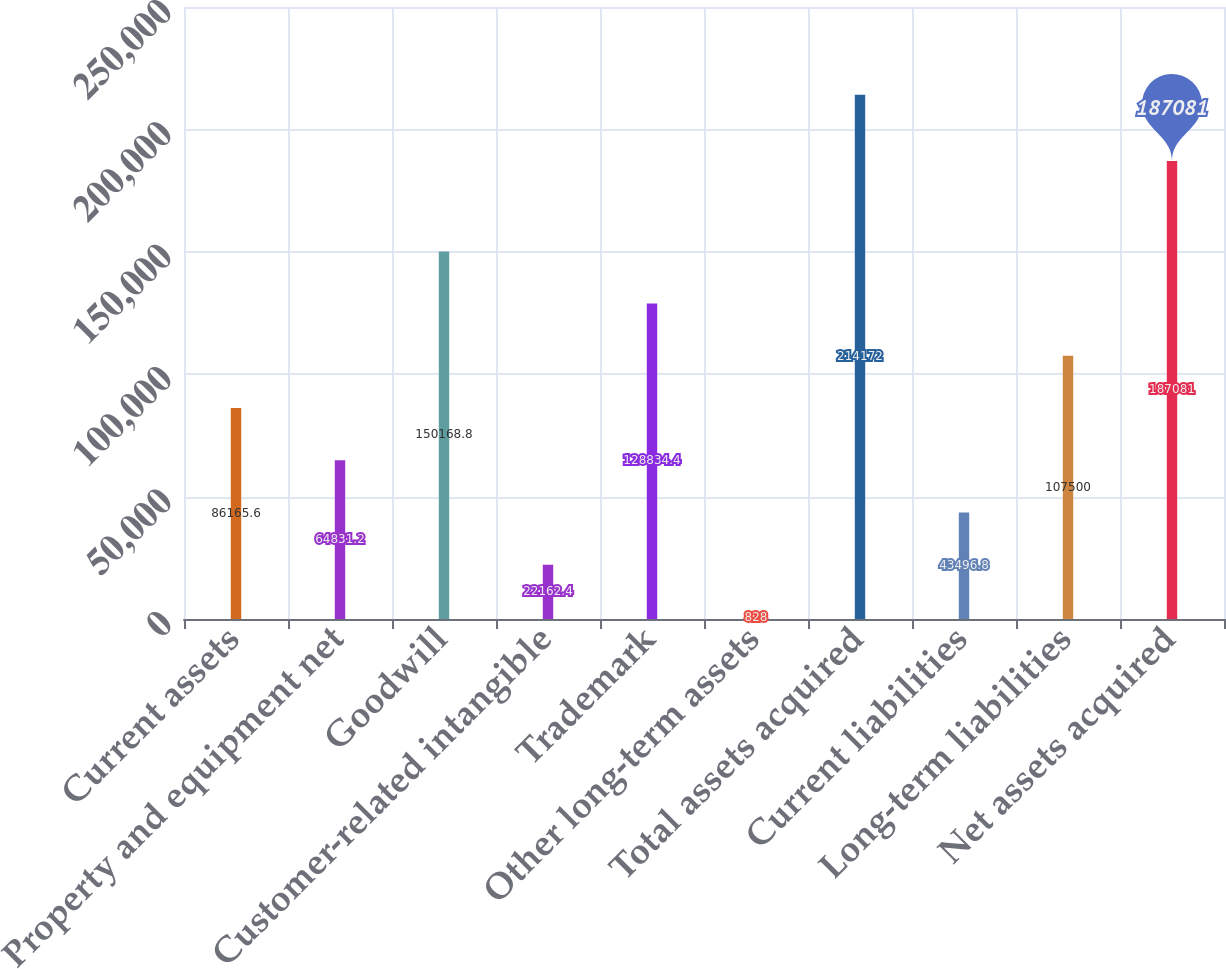<chart> <loc_0><loc_0><loc_500><loc_500><bar_chart><fcel>Current assets<fcel>Property and equipment net<fcel>Goodwill<fcel>Customer-related intangible<fcel>Trademark<fcel>Other long-term assets<fcel>Total assets acquired<fcel>Current liabilities<fcel>Long-term liabilities<fcel>Net assets acquired<nl><fcel>86165.6<fcel>64831.2<fcel>150169<fcel>22162.4<fcel>128834<fcel>828<fcel>214172<fcel>43496.8<fcel>107500<fcel>187081<nl></chart> 